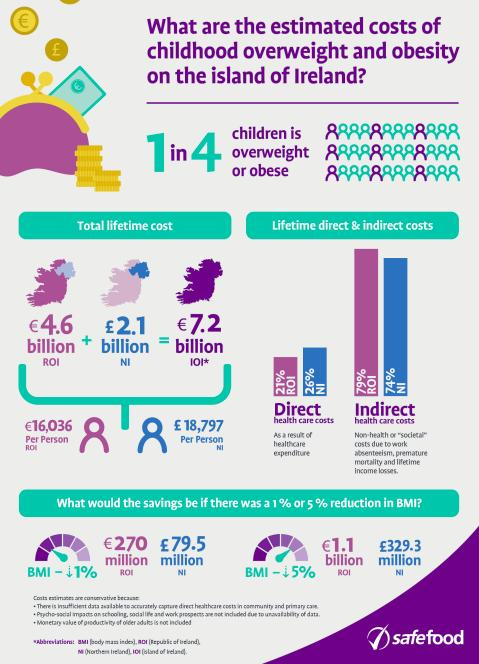Mention a couple of crucial points in this snapshot. A 5% reduction in Body Mass Index (BMI) in the Republic of Ireland and Northern Ireland would result in a difference of approximately 328.2 million pounds in savings on healthcare costs. In the Republic of Ireland and Northern Ireland, the total average percentage of direct health care costs is approximately 25%. The difference in savings between the Republic of Ireland and Northern Ireland if the Body Mass Index (BMI) is reduced by 1% is approximately £190.5 million. In the Republic of Ireland and Northern Ireland, the total average percentage of indirect health care costs is 76.5%. 